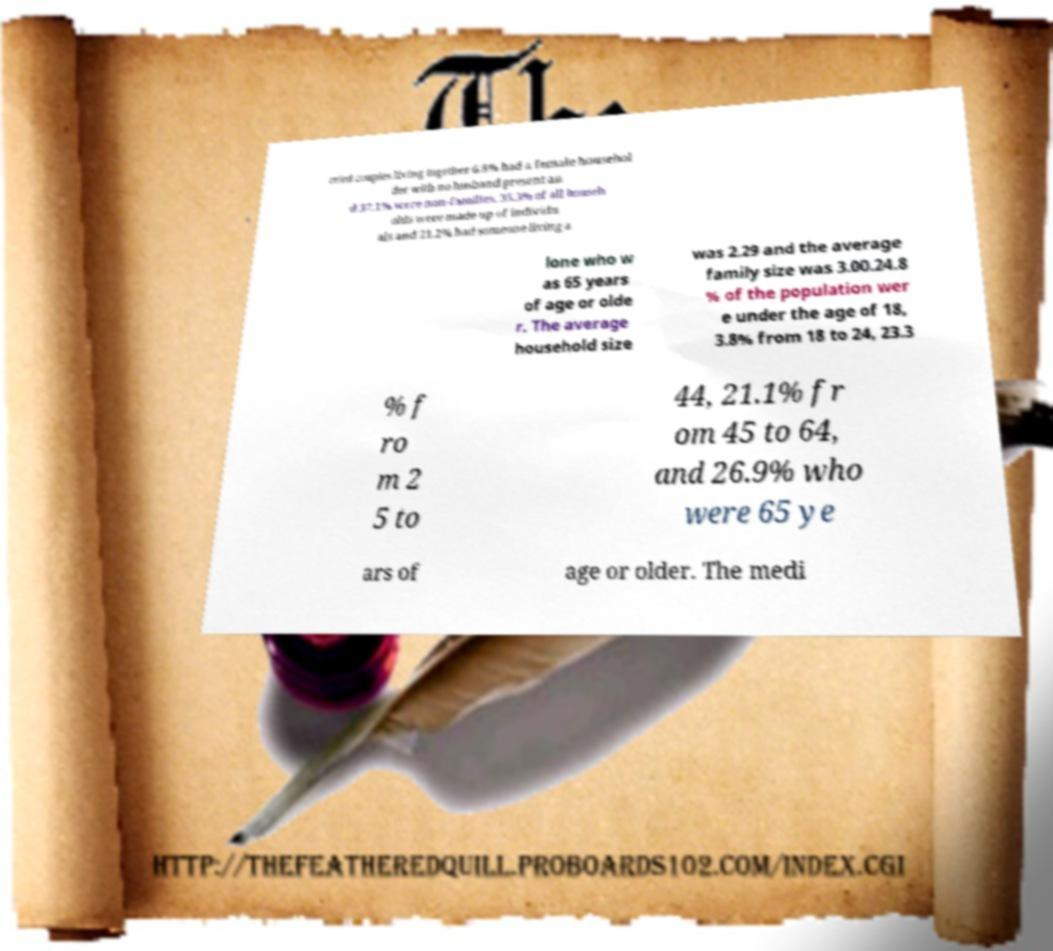Can you accurately transcribe the text from the provided image for me? rried couples living together 6.8% had a female househol der with no husband present an d 37.1% were non-families. 35.3% of all househ olds were made up of individu als and 21.2% had someone living a lone who w as 65 years of age or olde r. The average household size was 2.29 and the average family size was 3.00.24.8 % of the population wer e under the age of 18, 3.8% from 18 to 24, 23.3 % f ro m 2 5 to 44, 21.1% fr om 45 to 64, and 26.9% who were 65 ye ars of age or older. The medi 